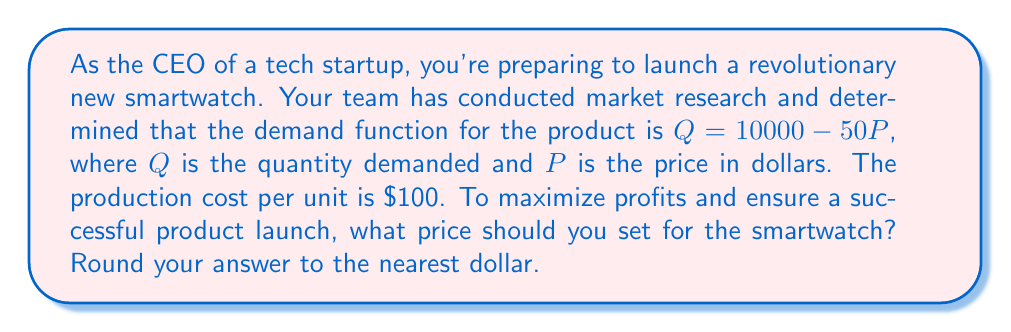Help me with this question. To solve this optimization problem, we'll follow these steps:

1) First, let's define our profit function. Profit is revenue minus cost:
   $$ \text{Profit} = \text{Revenue} - \text{Cost} $$

2) Revenue is price times quantity: $P \cdot Q$
   Cost is the per-unit cost times quantity: $100 \cdot Q$

3) Substituting the demand function $Q = 10000 - 50P$, we get:
   $$ \text{Profit} = P(10000 - 50P) - 100(10000 - 50P) $$

4) Expanding this:
   $$ \text{Profit} = 10000P - 50P^2 - 1000000 + 5000P $$
   $$ \text{Profit} = -50P^2 + 15000P - 1000000 $$

5) To find the maximum profit, we need to find where the derivative of this function equals zero:
   $$ \frac{d(\text{Profit})}{dP} = -100P + 15000 = 0 $$

6) Solving this equation:
   $$ -100P + 15000 = 0 $$
   $$ -100P = -15000 $$
   $$ P = 150 $$

7) To confirm this is a maximum (not a minimum), we can check the second derivative:
   $$ \frac{d^2(\text{Profit})}{dP^2} = -100 $$
   This is negative, confirming we've found a maximum.

8) Therefore, the profit-maximizing price is $\$150$.

This approach balances the steering committee's need for a clear strategy with a data-driven decision-making process, ensuring buy-in for the pricing strategy.
Answer: $150 